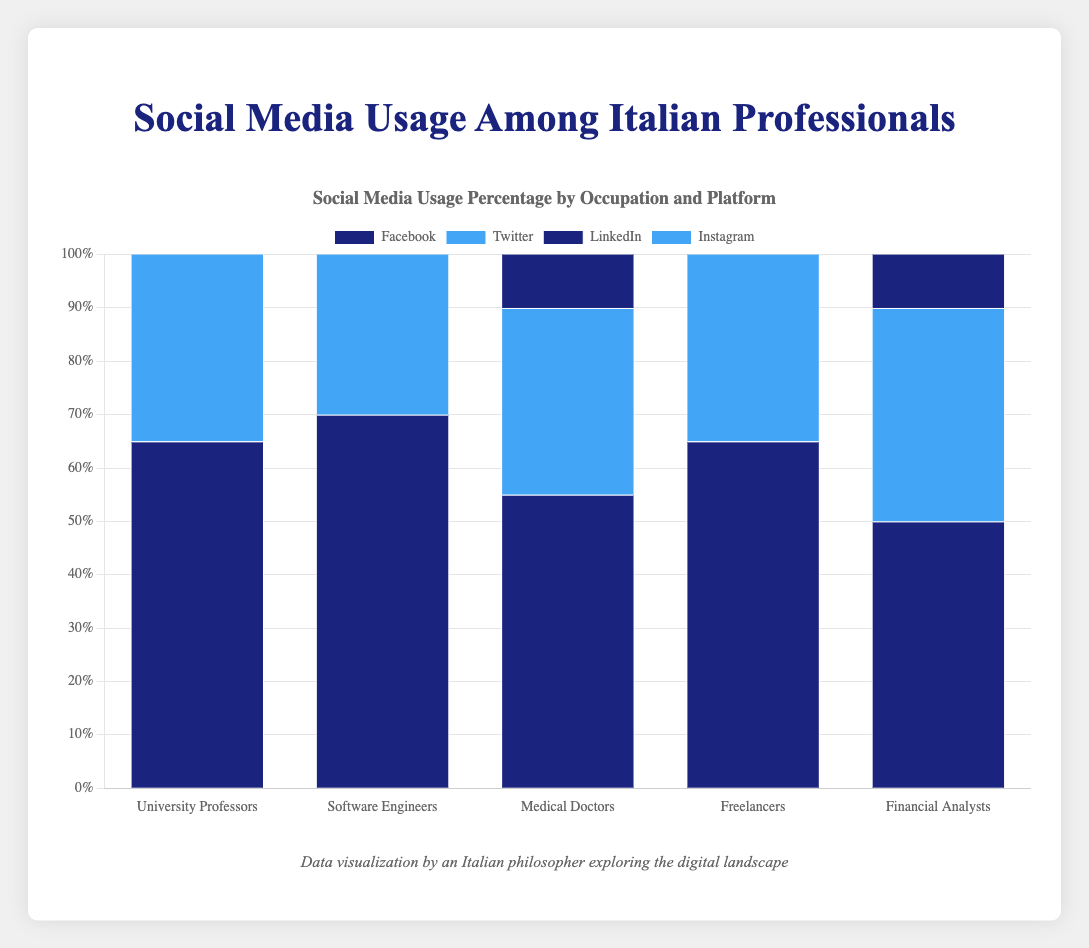Which occupation has the highest usage percentage on LinkedIn? Look for the tallest dark blue bar corresponding to LinkedIn usage. The highest bar is for Financial Analysts with 92%.
Answer: Financial Analysts Which social media platform do University Professors use the most? Compare the heights of all bars for University Professors. The tallest bar is for LinkedIn with 85%.
Answer: LinkedIn Which profession uses Instagram the most? Check the heights of the blue bars for Instagram across all professions. The tallest blue bar is for Freelancers with 80%.
Answer: Freelancers What is the difference in Twitter usage between Software Engineers and Medical Doctors? Find the blue bars for Twitter usage for both professions. Subtract Medical Doctors' 35% from Software Engineers' 60%. The difference is 25%.
Answer: 25% Which platforms do Financial Analysts prefer the least? Compare the heights of all bars representing Financial Analysts. The shortest bars are for Instagram (35%) and Twitter (40%).
Answer: Instagram and Twitter Among Medical Doctors, which platform has the lowest usage? Identify the shortest blue or dark blue bar for Medical Doctors. Twitter has the lowest with 35%.
Answer: Twitter What is the average usage percentage for Facebook across all professions? Sum the usage percentages for Facebook (65+70+55+65+50) and divide by the number of professions (5). (65+70+55+65+50) / 5 = 61
Answer: 61 Does LinkedIn usage exceed 80% for more than one profession? Check the dark blue bars for LinkedIn across different occupations. University Professors (85%), Software Engineers (90%), and Financial Analysts (92%) all exceed 80%.
Answer: Yes Compare the Instagram usage between Freelancers and Software Engineers. Which is higher? Compare the blue bars for Instagram usage. Freelancers have 80% while Software Engineers have 75%. Freelancers is higher.
Answer: Freelancers What is the combined usage percentage of Twitter for University Professors and Freelancers? Sum the Twitter usage percentages for both occupations: 45% (University Professors) + 55% (Freelancers). The combined is 45 + 55 = 100.
Answer: 100 